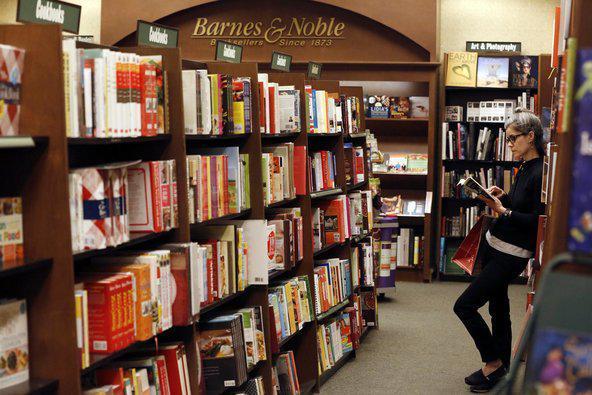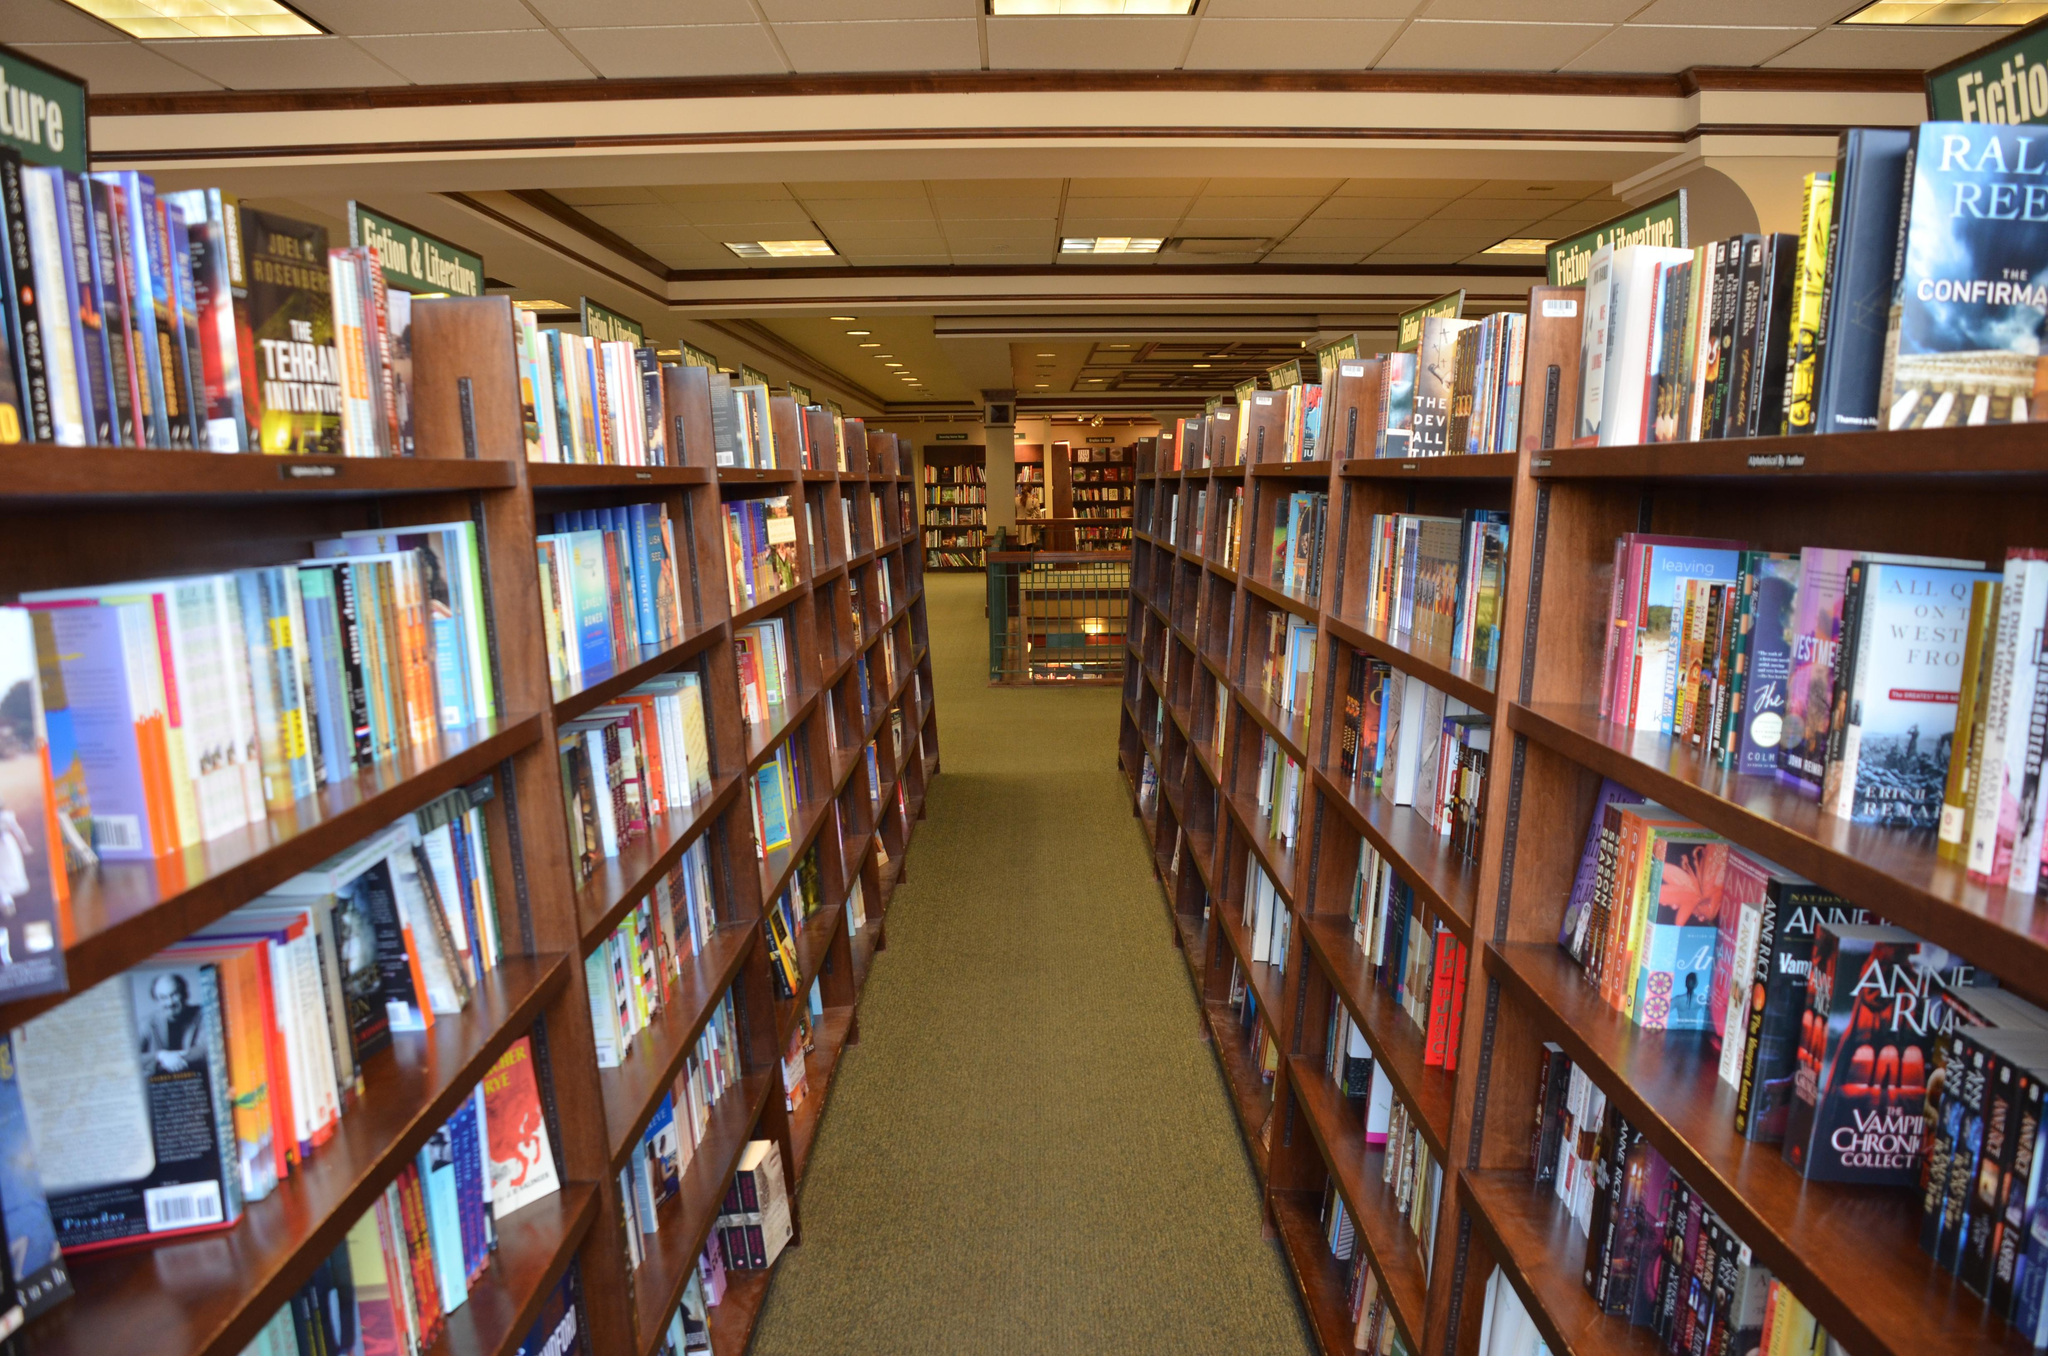The first image is the image on the left, the second image is the image on the right. Examine the images to the left and right. Is the description "There is exactly one person." accurate? Answer yes or no. Yes. The first image is the image on the left, the second image is the image on the right. Evaluate the accuracy of this statement regarding the images: "Someone is standing while reading a book.". Is it true? Answer yes or no. Yes. 